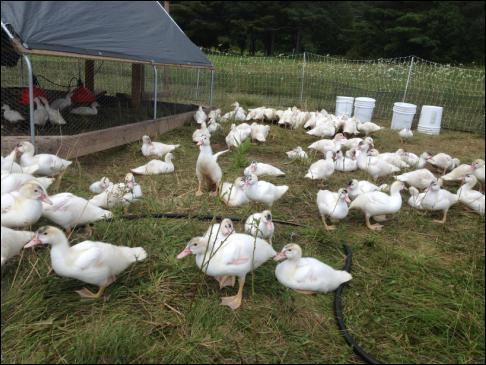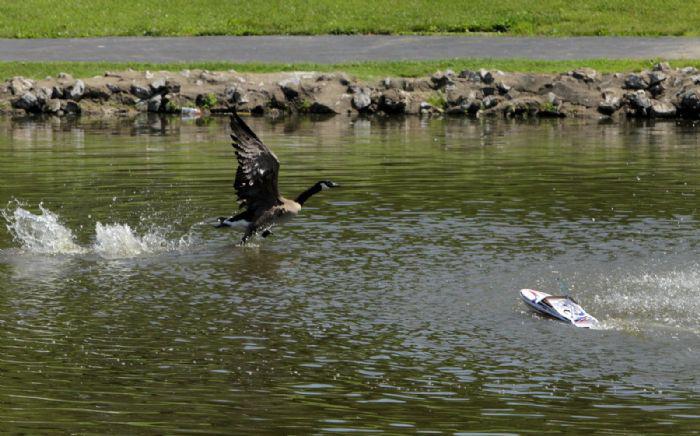The first image is the image on the left, the second image is the image on the right. For the images displayed, is the sentence "In at least one image there is at least one black and grey duck facing right in the water." factually correct? Answer yes or no. Yes. The first image is the image on the left, the second image is the image on the right. Assess this claim about the two images: "The canada geese are in the water.". Correct or not? Answer yes or no. Yes. 